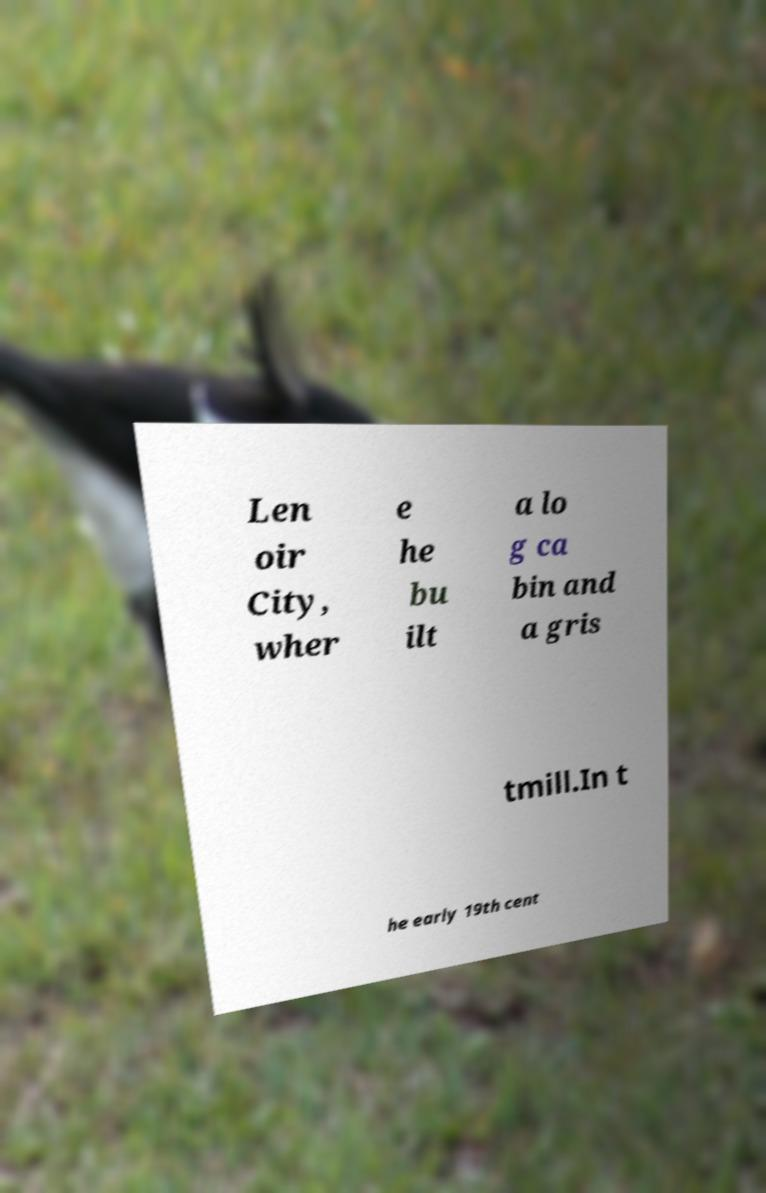There's text embedded in this image that I need extracted. Can you transcribe it verbatim? Len oir City, wher e he bu ilt a lo g ca bin and a gris tmill.In t he early 19th cent 